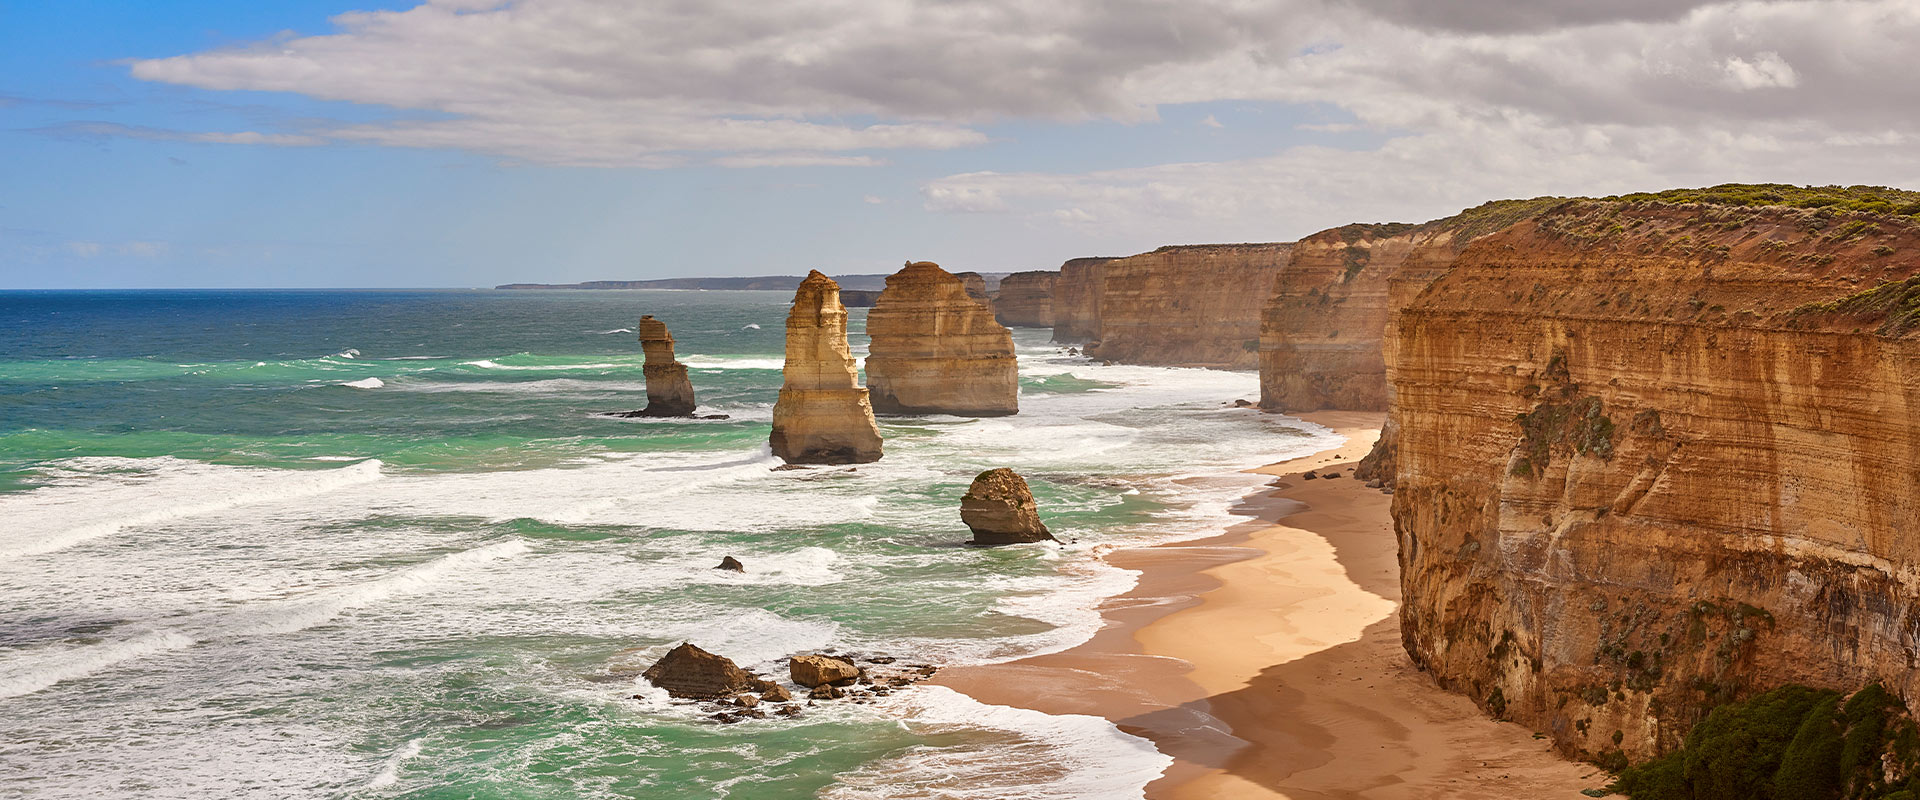Can you elaborate on the elements of the picture provided?
 This image captures the breathtaking view of the Twelve Apostles, a renowned landmark located off the shore of Port Campbell National Park in Victoria, Australia. The Twelve Apostles are a collection of limestone stacks that stand majestically against the backdrop of the deep blue-green ocean. The stacks themselves exhibit various shades of orange and tan, creating a striking contrast with the surrounding waters. The photo is taken from a high vantage point, offering a panoramic view of the stacks and the ocean. The sky overhead is mostly cloudy, with patches of blue sky peeking through, adding to the overall dramatic effect of the scene. The perspective of the photo is from the left side of the stacks, looking towards the right, providing a unique viewpoint of this iconic Australian landmark. 